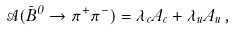<formula> <loc_0><loc_0><loc_500><loc_500>\mathcal { A } ( \bar { B } ^ { 0 } \to \pi ^ { + } \pi ^ { - } ) = \lambda _ { c } A _ { c } + \lambda _ { u } A _ { u } \, ,</formula> 